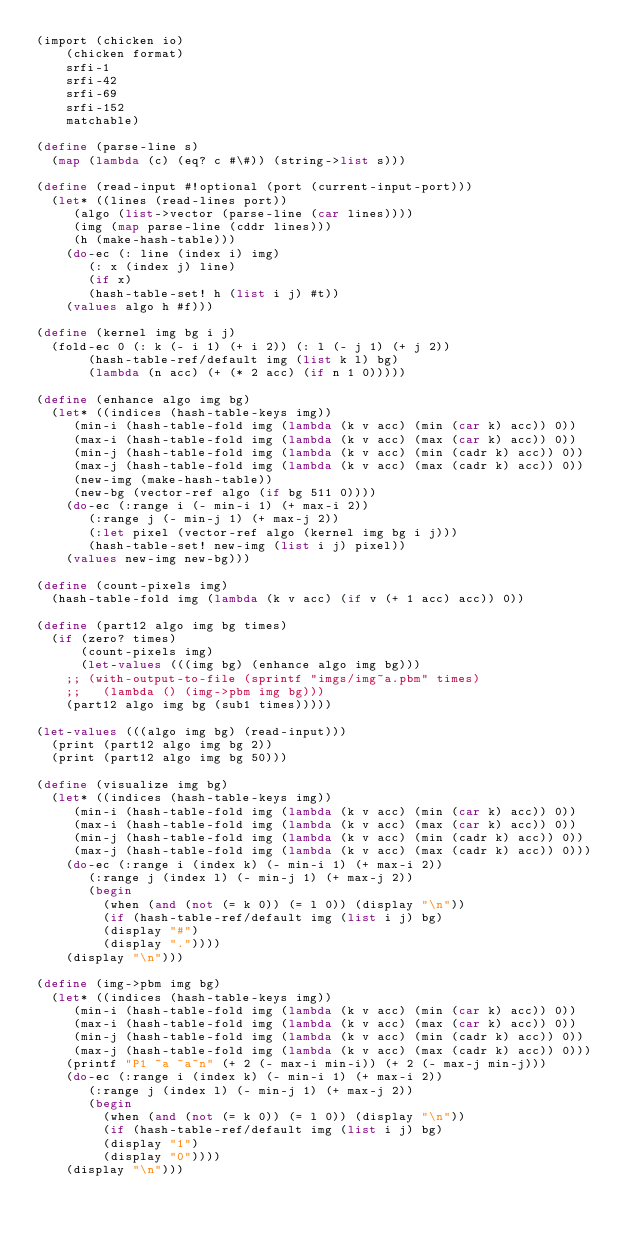Convert code to text. <code><loc_0><loc_0><loc_500><loc_500><_Scheme_>(import (chicken io)
	(chicken format)
	srfi-1
	srfi-42
	srfi-69
	srfi-152
	matchable)

(define (parse-line s)
  (map (lambda (c) (eq? c #\#)) (string->list s)))

(define (read-input #!optional (port (current-input-port)))
  (let* ((lines (read-lines port))
	 (algo (list->vector (parse-line (car lines))))
	 (img (map parse-line (cddr lines)))
	 (h (make-hash-table)))
    (do-ec (: line (index i) img)
	   (: x (index j) line)
	   (if x)
	   (hash-table-set! h (list i j) #t))
    (values algo h #f)))

(define (kernel img bg i j)
  (fold-ec 0 (: k (- i 1) (+ i 2)) (: l (- j 1) (+ j 2))
	   (hash-table-ref/default img (list k l) bg)
	   (lambda (n acc) (+ (* 2 acc) (if n 1 0)))))

(define (enhance algo img bg)
  (let* ((indices (hash-table-keys img))
	 (min-i (hash-table-fold img (lambda (k v acc) (min (car k) acc)) 0))
	 (max-i (hash-table-fold img (lambda (k v acc) (max (car k) acc)) 0))
	 (min-j (hash-table-fold img (lambda (k v acc) (min (cadr k) acc)) 0))
	 (max-j (hash-table-fold img (lambda (k v acc) (max (cadr k) acc)) 0))
	 (new-img (make-hash-table))
	 (new-bg (vector-ref algo (if bg 511 0))))
    (do-ec (:range i (- min-i 1) (+ max-i 2))
	   (:range j (- min-j 1) (+ max-j 2))
	   (:let pixel (vector-ref algo (kernel img bg i j)))
	   (hash-table-set! new-img (list i j) pixel))
    (values new-img new-bg)))

(define (count-pixels img)
  (hash-table-fold img (lambda (k v acc) (if v (+ 1 acc) acc)) 0))

(define (part12 algo img bg times)
  (if (zero? times)
      (count-pixels img)
      (let-values (((img bg) (enhance algo img bg)))
	;; (with-output-to-file (sprintf "imgs/img~a.pbm" times)
	;;   (lambda () (img->pbm img bg)))
	(part12 algo img bg (sub1 times)))))

(let-values (((algo img bg) (read-input)))
  (print (part12 algo img bg 2))
  (print (part12 algo img bg 50)))

(define (visualize img bg)
  (let* ((indices (hash-table-keys img))
	 (min-i (hash-table-fold img (lambda (k v acc) (min (car k) acc)) 0))
	 (max-i (hash-table-fold img (lambda (k v acc) (max (car k) acc)) 0))
	 (min-j (hash-table-fold img (lambda (k v acc) (min (cadr k) acc)) 0))
	 (max-j (hash-table-fold img (lambda (k v acc) (max (cadr k) acc)) 0)))
    (do-ec (:range i (index k) (- min-i 1) (+ max-i 2))
	   (:range j (index l) (- min-j 1) (+ max-j 2))
	   (begin
	     (when (and (not (= k 0)) (= l 0)) (display "\n"))
	     (if (hash-table-ref/default img (list i j) bg)
		 (display "#")
		 (display "."))))
    (display "\n")))

(define (img->pbm img bg)
  (let* ((indices (hash-table-keys img))
	 (min-i (hash-table-fold img (lambda (k v acc) (min (car k) acc)) 0))
	 (max-i (hash-table-fold img (lambda (k v acc) (max (car k) acc)) 0))
	 (min-j (hash-table-fold img (lambda (k v acc) (min (cadr k) acc)) 0))
	 (max-j (hash-table-fold img (lambda (k v acc) (max (cadr k) acc)) 0)))
    (printf "P1 ~a ~a~n" (+ 2 (- max-i min-i)) (+ 2 (- max-j min-j)))
    (do-ec (:range i (index k) (- min-i 1) (+ max-i 2))
	   (:range j (index l) (- min-j 1) (+ max-j 2))
	   (begin
	     (when (and (not (= k 0)) (= l 0)) (display "\n"))
	     (if (hash-table-ref/default img (list i j) bg)
		 (display "1")
		 (display "0"))))
    (display "\n")))

</code> 